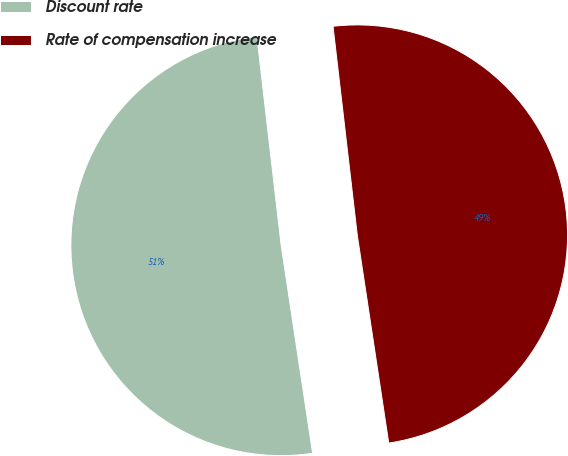Convert chart to OTSL. <chart><loc_0><loc_0><loc_500><loc_500><pie_chart><fcel>Discount rate<fcel>Rate of compensation increase<nl><fcel>50.55%<fcel>49.45%<nl></chart> 